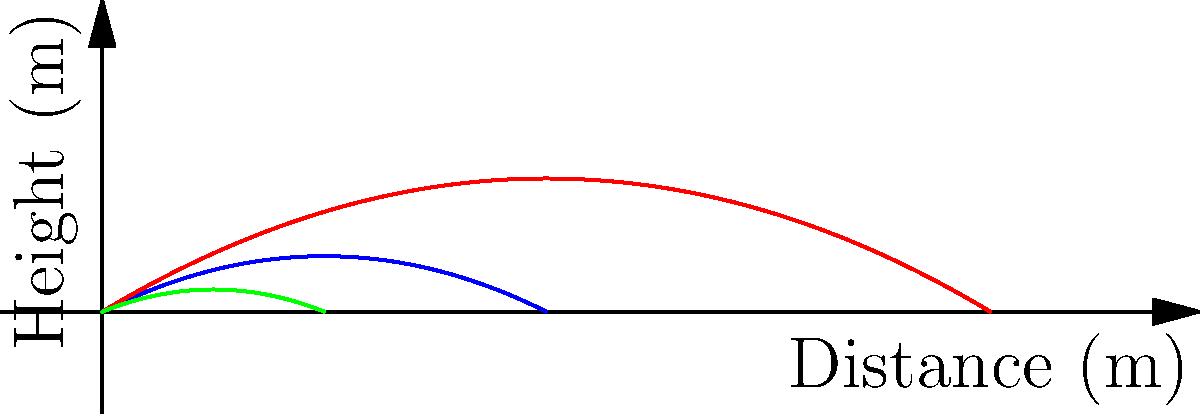As a baseball coach, you understand the importance of launch angle in hitting. The graph shows the trajectories of baseballs hit at three different angles: 30°, 45°, and 60°. Based on the graph, which angle produces the hit with the greatest distance, and how does this relate to the optimal launch angle for home runs in professional baseball? To answer this question, we need to analyze the graph and apply our baseball knowledge:

1. Observe the trajectories:
   - 30° (blue): Travels far but doesn't reach as high
   - 45° (red): Travels the farthest and reaches a moderate height
   - 60° (green): Reaches the highest point but travels the shortest distance

2. Identify the angle with the greatest distance:
   The 45° angle (red line) clearly travels the farthest horizontally.

3. Relate to optimal launch angle in professional baseball:
   - The optimal launch angle for home runs in MLB is typically between 25° and 35°.
   - Our graph shows 45° as the farthest, which seems to contradict this.

4. Explain the discrepancy:
   - The graph is a simplified model that doesn't account for factors like air resistance, spin, and ball velocity.
   - In real baseball, these factors cause the optimal angle to be lower than 45°.
   - Higher launch angles (like 45° or 60°) give the ball more time in the air, increasing the effects of air resistance and reducing overall distance.

5. Conclusion:
   While the graph shows 45° as optimal, real-world baseball requires a lower angle (25°-35°) for maximum distance due to additional factors not represented in this simplified model.
Answer: 45° produces the greatest distance in the model, but 25°-35° is optimal in real baseball due to air resistance and other factors. 